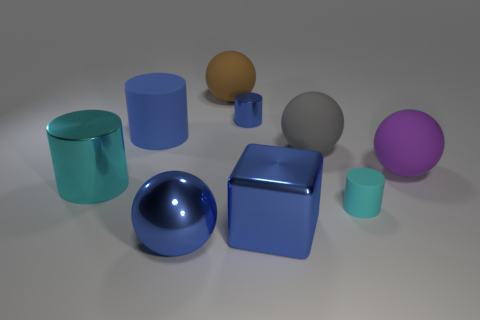Subtract all small shiny cylinders. How many cylinders are left? 3 Subtract all brown spheres. How many blue cylinders are left? 2 Subtract all blue spheres. How many spheres are left? 3 Subtract 2 spheres. How many spheres are left? 2 Add 1 big green rubber cylinders. How many objects exist? 10 Subtract all cyan spheres. Subtract all blue cylinders. How many spheres are left? 4 Subtract all balls. How many objects are left? 5 Subtract all big blocks. Subtract all spheres. How many objects are left? 4 Add 9 cyan metal objects. How many cyan metal objects are left? 10 Add 7 big brown matte balls. How many big brown matte balls exist? 8 